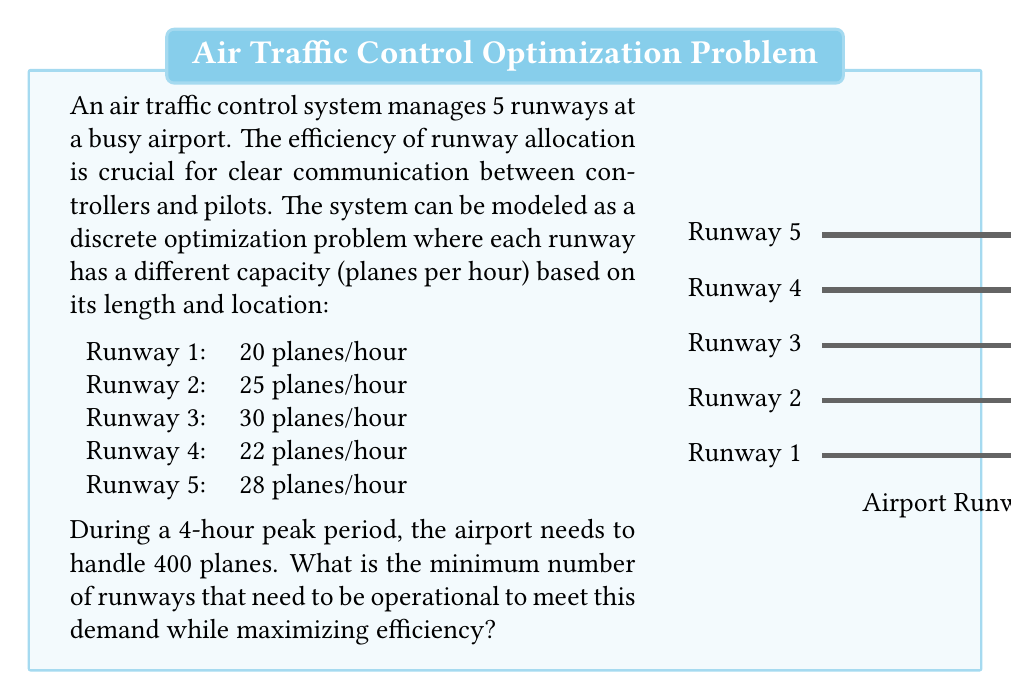Can you solve this math problem? To solve this problem, we'll use a greedy approach in discrete optimization:

1) First, calculate the total capacity of all runways per hour:
   $20 + 25 + 30 + 22 + 28 = 125$ planes/hour

2) Calculate the required capacity for 4 hours:
   $400 \div 4 = 100$ planes/hour

3) Sort the runways by capacity in descending order:
   Runway 3: 30 planes/hour
   Runway 5: 28 planes/hour
   Runway 2: 25 planes/hour
   Runway 4: 22 planes/hour
   Runway 1: 20 planes/hour

4) Add runways until we meet or exceed the required capacity:
   Runway 3: 30 planes/hour (Total: 30)
   Runway 5: 28 planes/hour (Total: 58)
   Runway 2: 25 planes/hour (Total: 83)
   Runway 4: 22 planes/hour (Total: 105)

5) After adding the 4th runway, we exceed the required capacity of 100 planes/hour.

Therefore, the minimum number of runways needed is 4.

This solution maximizes efficiency by using the runways with the highest capacity first, ensuring clear communication between air traffic controllers and pilots by minimizing the number of active runways to manage.
Answer: 4 runways 